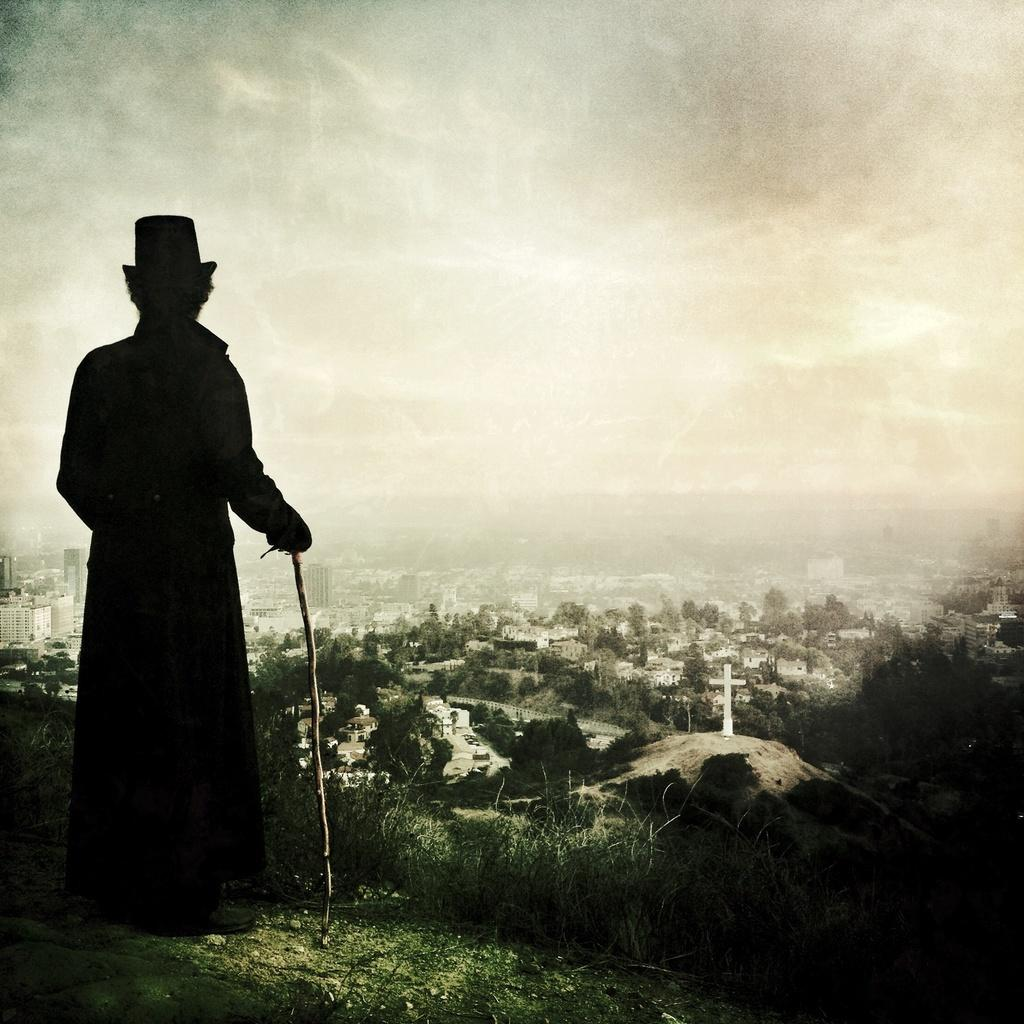What can be observed about the image itself? The image appears to be edited. Who or what is present in the image? There is a person in the image. What is the person holding in the image? The person is holding a stick. What type of terrain is visible in the image? There is grass visible in the image. What can be seen in the distance in the image? There are buildings, trees, and the sky visible in the background of the image. How does the person increase the amount of honey in the image? There is no honey present in the image, so it cannot be increased. What type of burn can be seen on the person's hand in the image? There is no burn visible on the person's hand in the image. 